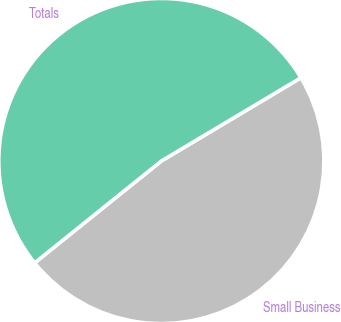Convert chart to OTSL. <chart><loc_0><loc_0><loc_500><loc_500><pie_chart><fcel>Small Business<fcel>Totals<nl><fcel>47.78%<fcel>52.22%<nl></chart> 